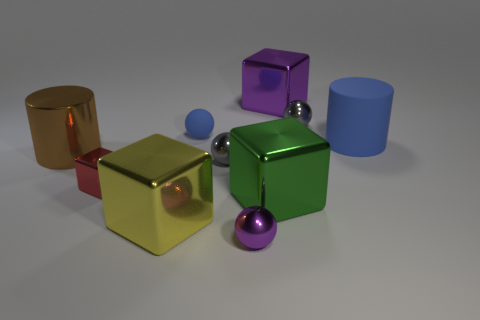The other small rubber thing that is the same shape as the tiny purple thing is what color?
Your response must be concise. Blue. There is a sphere that is made of the same material as the blue cylinder; what is its color?
Provide a short and direct response. Blue. Is the number of large matte things that are in front of the small red cube the same as the number of blue rubber cylinders?
Your answer should be compact. No. Does the purple thing that is behind the green metallic thing have the same size as the small red metallic cube?
Your response must be concise. No. What color is the metallic block that is the same size as the blue ball?
Offer a very short reply. Red. There is a gray shiny thing that is in front of the gray object behind the big brown shiny cylinder; are there any tiny balls in front of it?
Your answer should be very brief. Yes. What material is the gray ball in front of the brown cylinder?
Ensure brevity in your answer.  Metal. There is a big yellow thing; does it have the same shape as the tiny thing that is to the left of the blue ball?
Provide a short and direct response. Yes. Are there an equal number of large green metal blocks on the left side of the small red metallic block and big cubes in front of the large purple metal object?
Your response must be concise. No. What number of other objects are the same material as the large green block?
Your answer should be very brief. 7. 